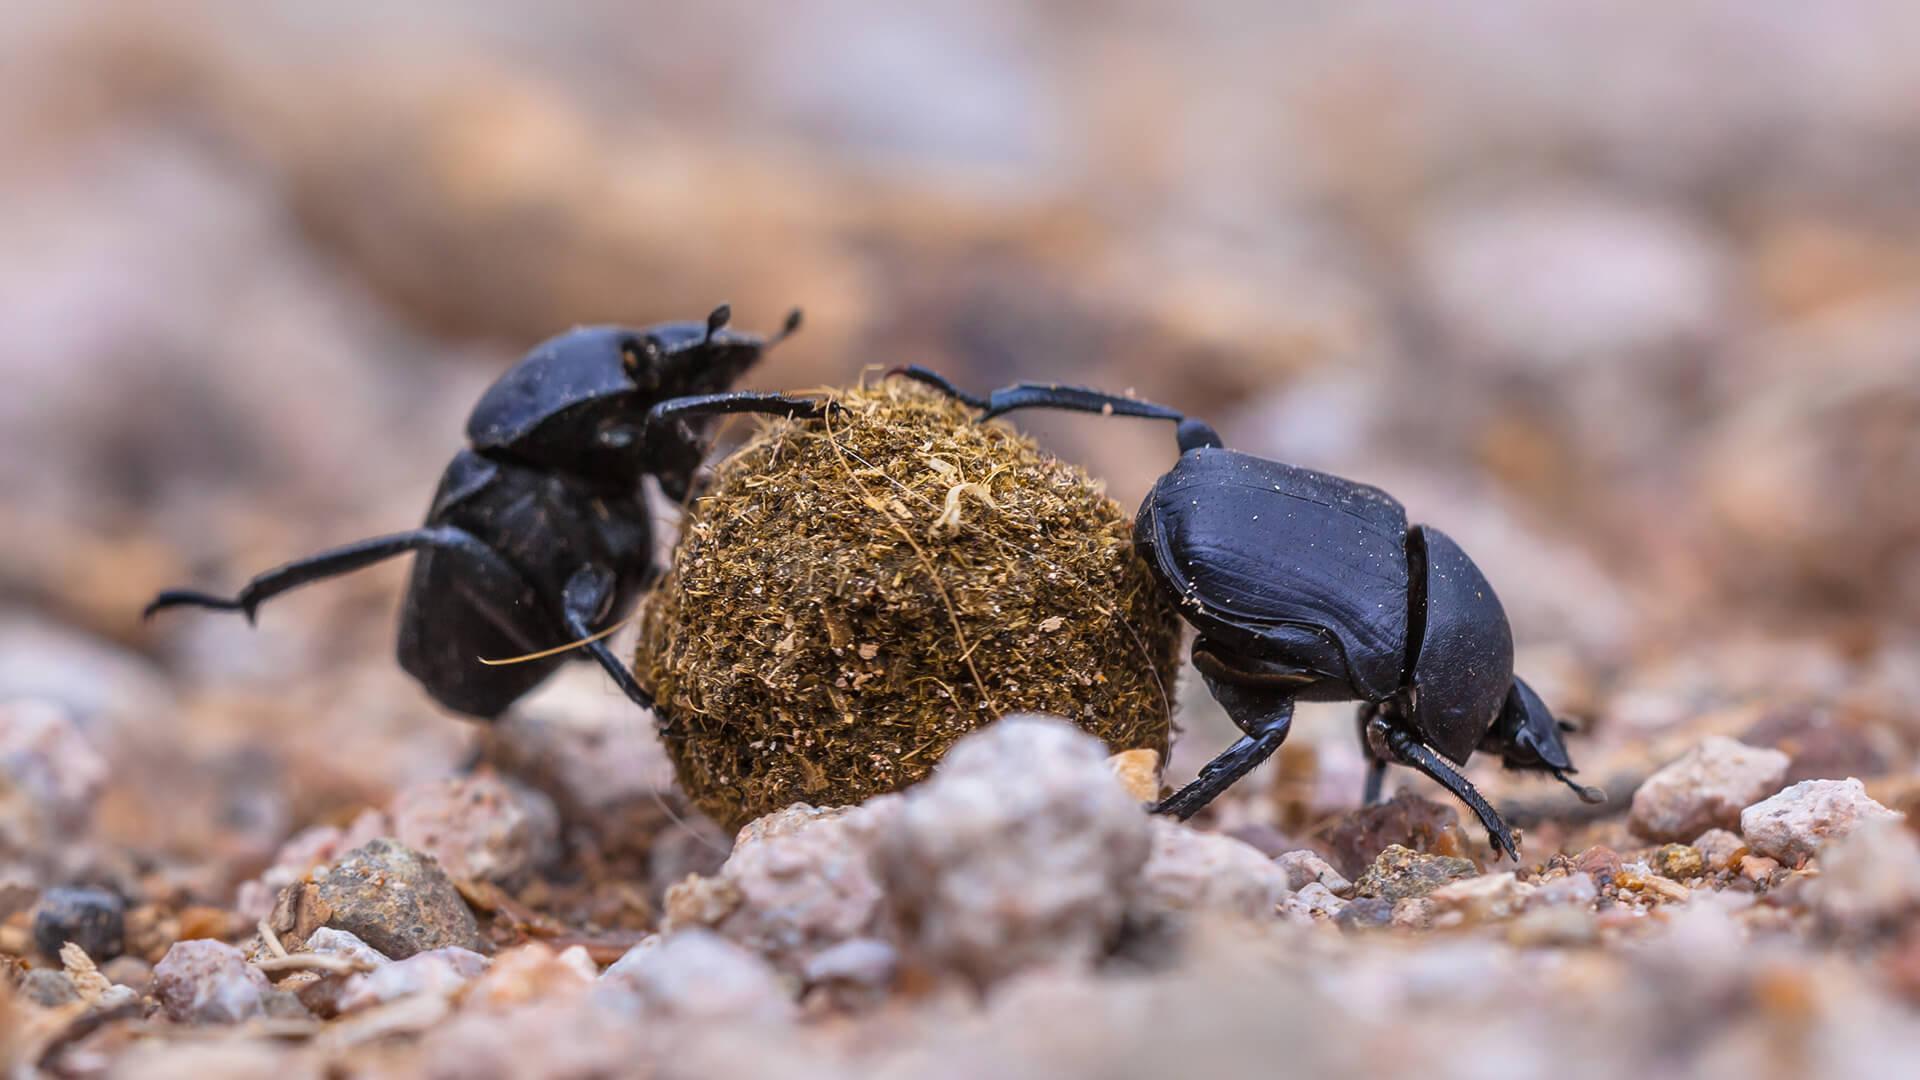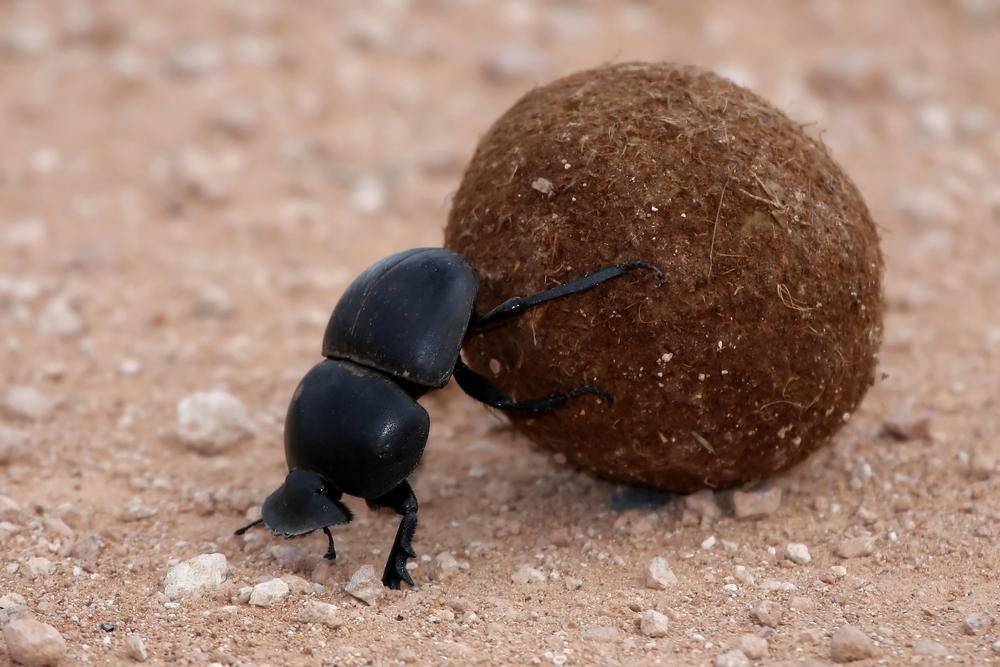The first image is the image on the left, the second image is the image on the right. For the images displayed, is the sentence "There are two beatles in total." factually correct? Answer yes or no. No. 